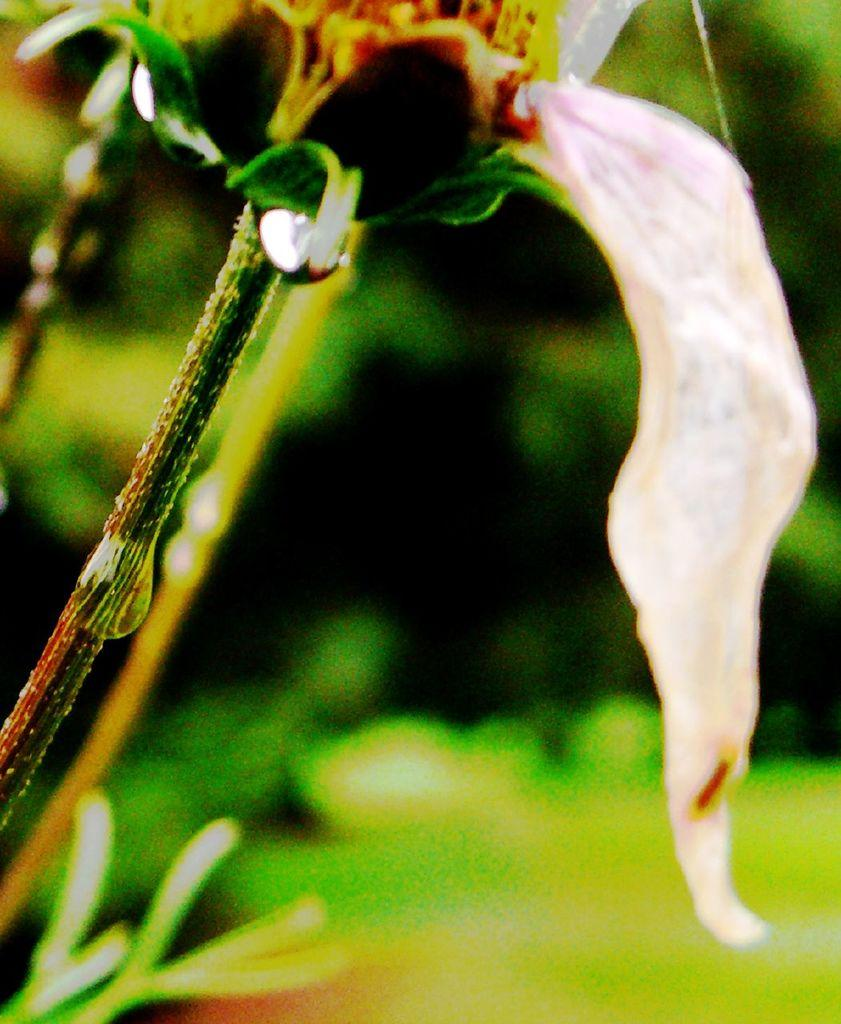What is the main subject of the image? The main subject of the image is a flower. How many roots does the giraffe have in the image? There is no giraffe present in the image, and therefore no roots can be associated with it. 